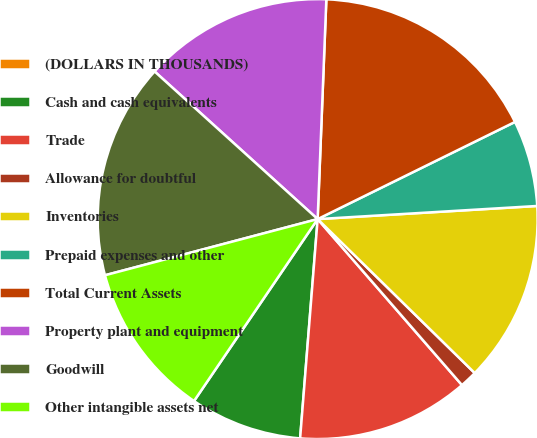Convert chart. <chart><loc_0><loc_0><loc_500><loc_500><pie_chart><fcel>(DOLLARS IN THOUSANDS)<fcel>Cash and cash equivalents<fcel>Trade<fcel>Allowance for doubtful<fcel>Inventories<fcel>Prepaid expenses and other<fcel>Total Current Assets<fcel>Property plant and equipment<fcel>Goodwill<fcel>Other intangible assets net<nl><fcel>0.0%<fcel>8.23%<fcel>12.66%<fcel>1.27%<fcel>13.29%<fcel>6.33%<fcel>17.09%<fcel>13.92%<fcel>15.82%<fcel>11.39%<nl></chart> 